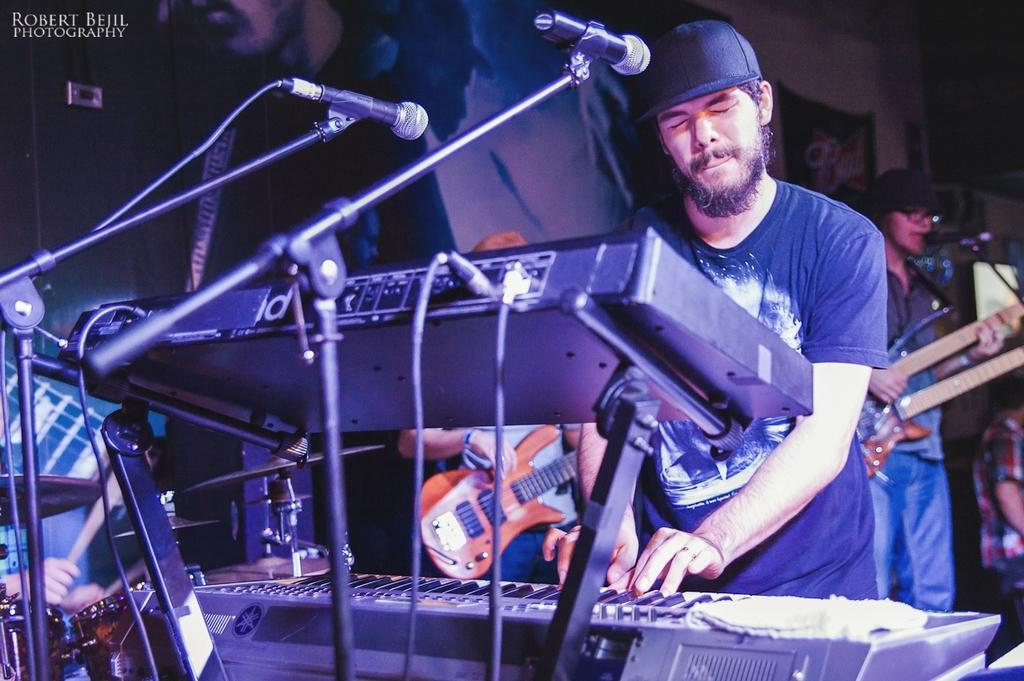How many people are in the image? There are three people in the image. What are the people doing in the image? The people are playing musical instruments. What can be seen in the background of the image? There is a wall visible in the background. What is used for amplifying sound in the image? There is a microphone in the image, and it has a stand associated with it. What type of wool is being spun on the rod in the image? There is no wool or rod present in the image; it features three people playing musical instruments and a microphone with a stand. 